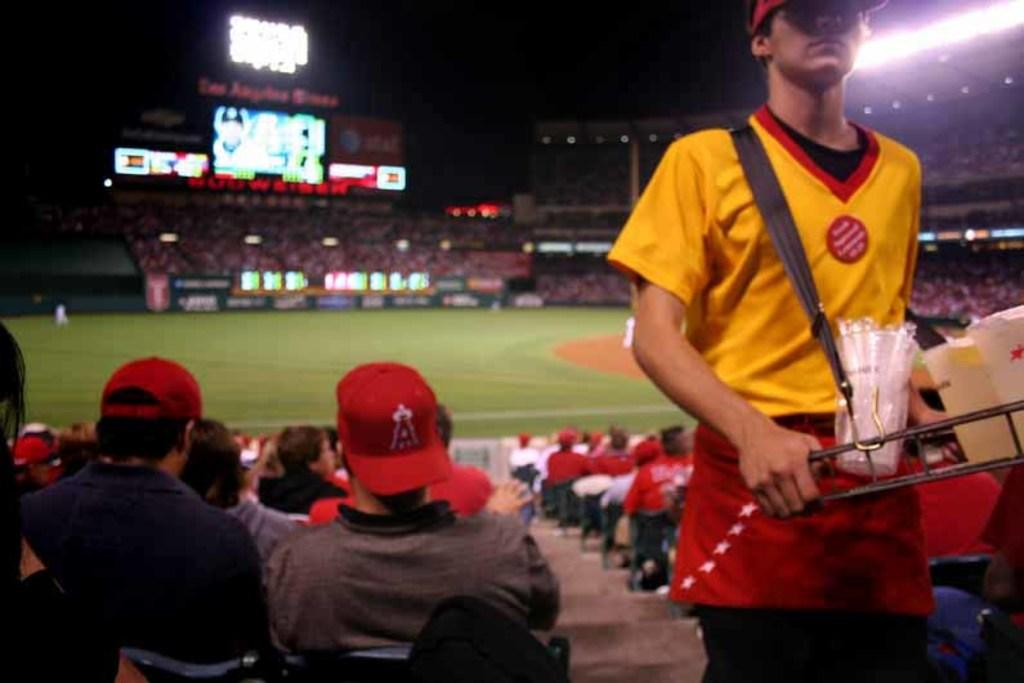<image>
Give a short and clear explanation of the subsequent image. Spectators are seated at a sporting event in a stadium, with one wearing a red baseball cap with the letter "A" visible. 